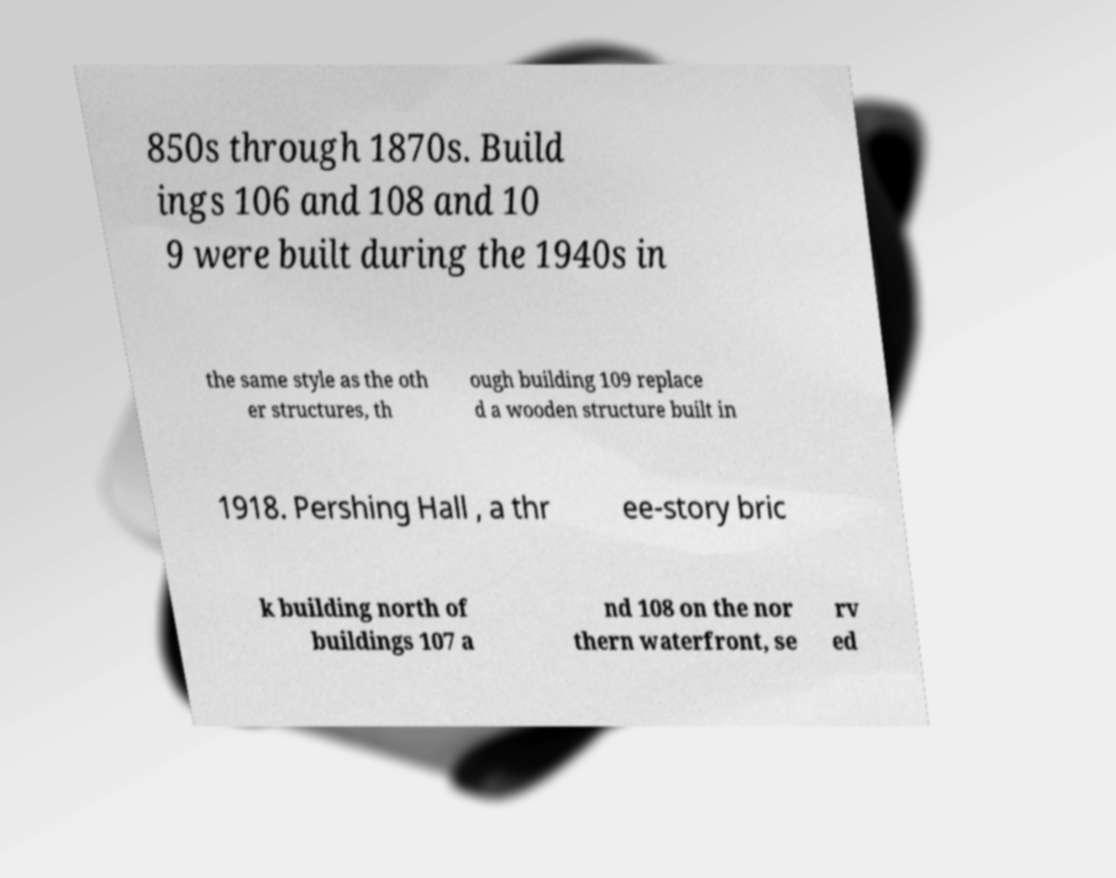Could you assist in decoding the text presented in this image and type it out clearly? 850s through 1870s. Build ings 106 and 108 and 10 9 were built during the 1940s in the same style as the oth er structures, th ough building 109 replace d a wooden structure built in 1918. Pershing Hall , a thr ee-story bric k building north of buildings 107 a nd 108 on the nor thern waterfront, se rv ed 